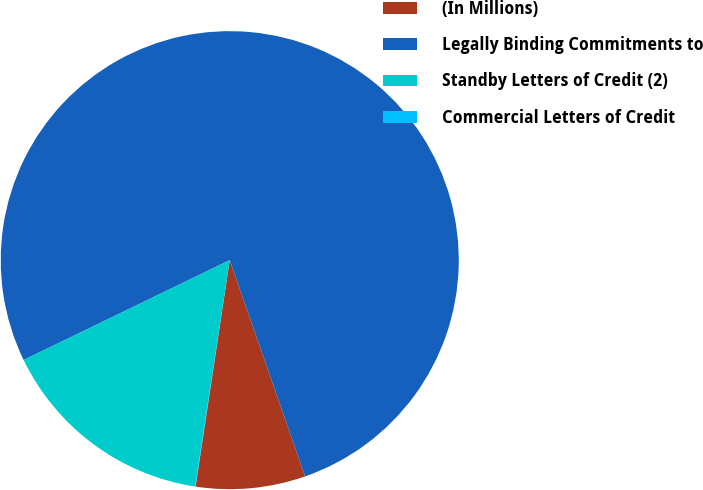<chart> <loc_0><loc_0><loc_500><loc_500><pie_chart><fcel>(In Millions)<fcel>Legally Binding Commitments to<fcel>Standby Letters of Credit (2)<fcel>Commercial Letters of Credit<nl><fcel>7.72%<fcel>76.85%<fcel>15.4%<fcel>0.04%<nl></chart> 